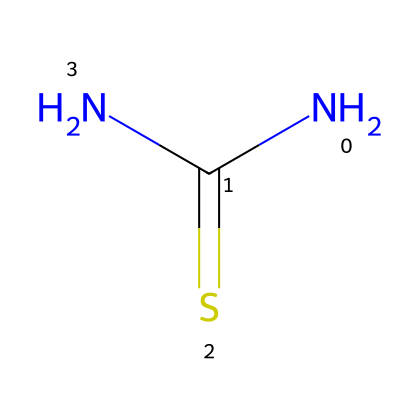What is the name of this chemical? The SMILES representation NC(=S)N corresponds to the chemical thiourea, which is commonly recognized in organic chemistry.
Answer: thiourea How many nitrogen atoms are present in thiourea? By analyzing the structure, we can see that there are two nitrogen atoms (N) represented in the SMILES as "N" before and after the carbon (C) atom.
Answer: 2 What is the total number of hydrogen atoms in thiourea? There are four hydrogen atoms implied in the structure. The nitrogen atoms form three bonds with hydrogen in total, and the carbon has one bond to another nitrogen atom implicitly accounting for the remaining hydrogens.
Answer: 4 What is the oxidation state of sulfur in thiourea? In thiourea, sulfur is directly bonded to carbon and nitrogen, and it typically exhibits an oxidation state of -2 in organosulfur compounds since it has gained two electrons compared to elemental sulfur.
Answer: -2 What type of bonding is primarily present in thiourea? The structure reveals both covalent bonds (between carbon, nitrogen, and sulfur) and coordinate bonding, especially involving nitrogen atoms sharing electron pairs with carbon or sulfur, indicating significant covalent character.
Answer: covalent What feature of thiourea allows it to act as a flame retardant? The presence of sulfur in thiourea contributes to its flame-retardant properties, as sulfur-containing groups can interrupt combustion processes. This is critical when considering its application in textiles.
Answer: sulfur How does the presence of the amine group impact the properties of thiourea? The amine (NH2) groups in thiourea enhance its ability to hydrogen bond, impacting its solubility and effectiveness in different formulations such as flame retardants. This increases its versatility as a chemical in various applications.
Answer: hydrogen bond 